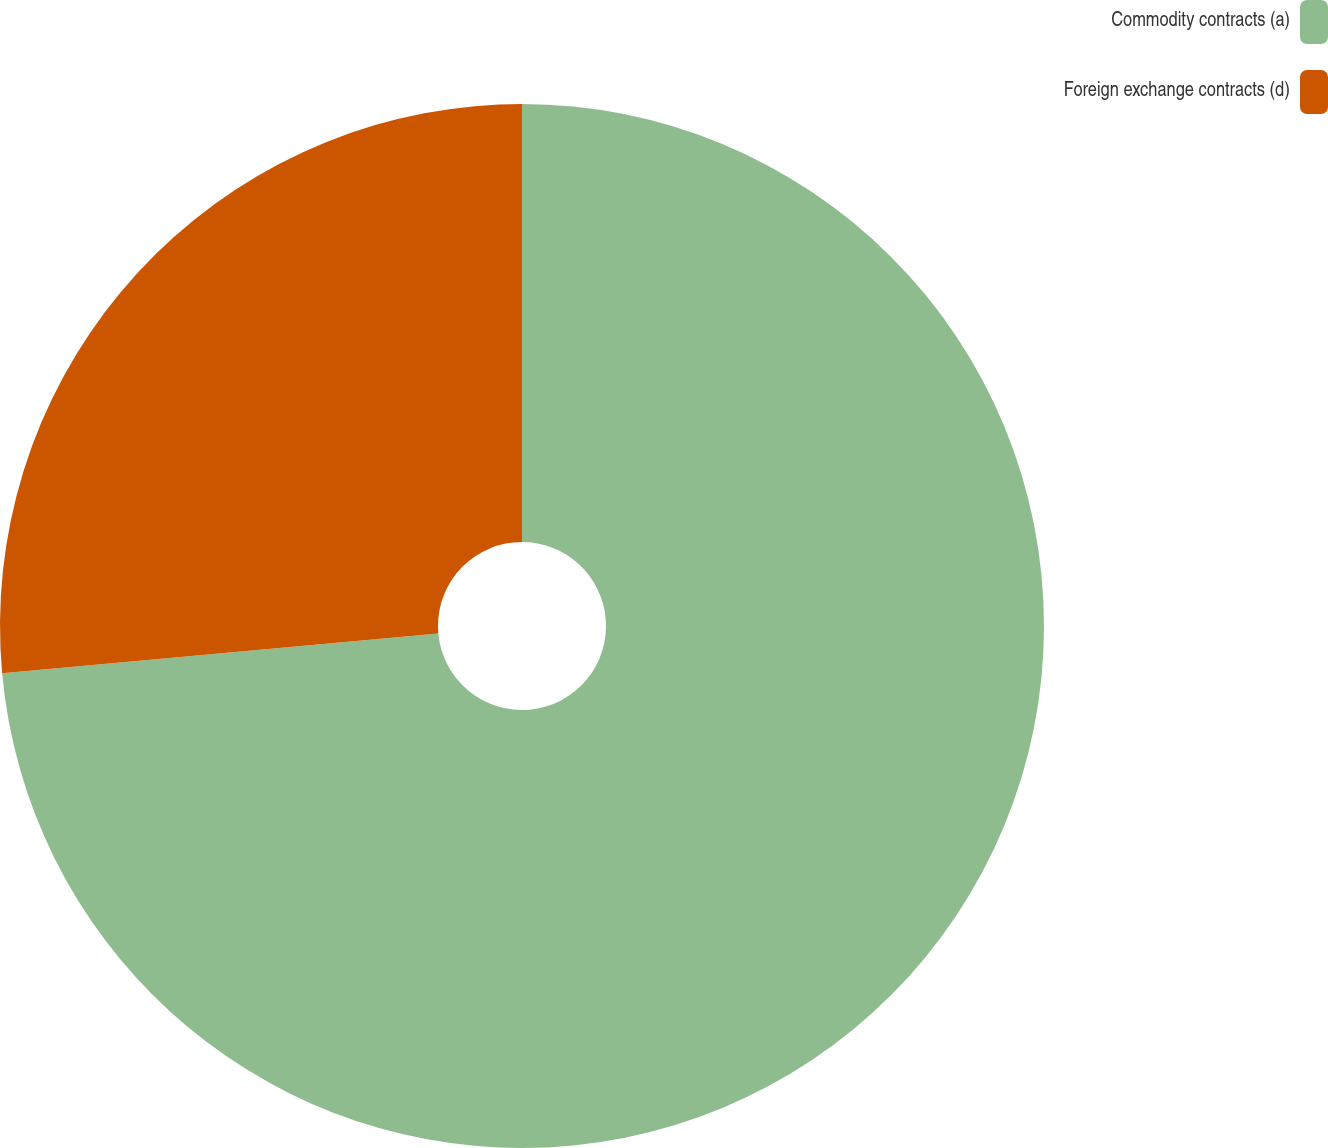Convert chart to OTSL. <chart><loc_0><loc_0><loc_500><loc_500><pie_chart><fcel>Commodity contracts (a)<fcel>Foreign exchange contracts (d)<nl><fcel>73.56%<fcel>26.44%<nl></chart> 